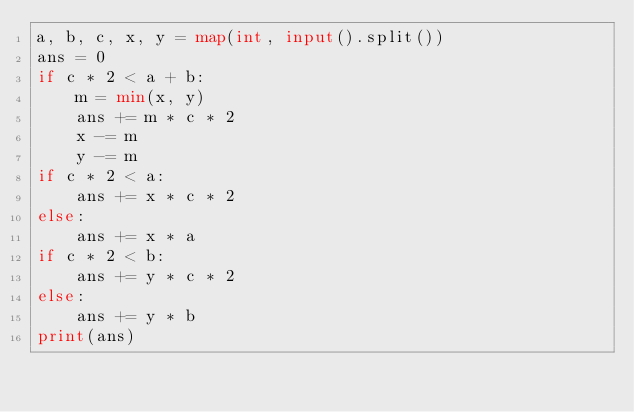Convert code to text. <code><loc_0><loc_0><loc_500><loc_500><_Python_>a, b, c, x, y = map(int, input().split())
ans = 0
if c * 2 < a + b:
    m = min(x, y)
    ans += m * c * 2
    x -= m
    y -= m
if c * 2 < a:
    ans += x * c * 2
else:
    ans += x * a
if c * 2 < b:
    ans += y * c * 2
else:
    ans += y * b
print(ans)</code> 